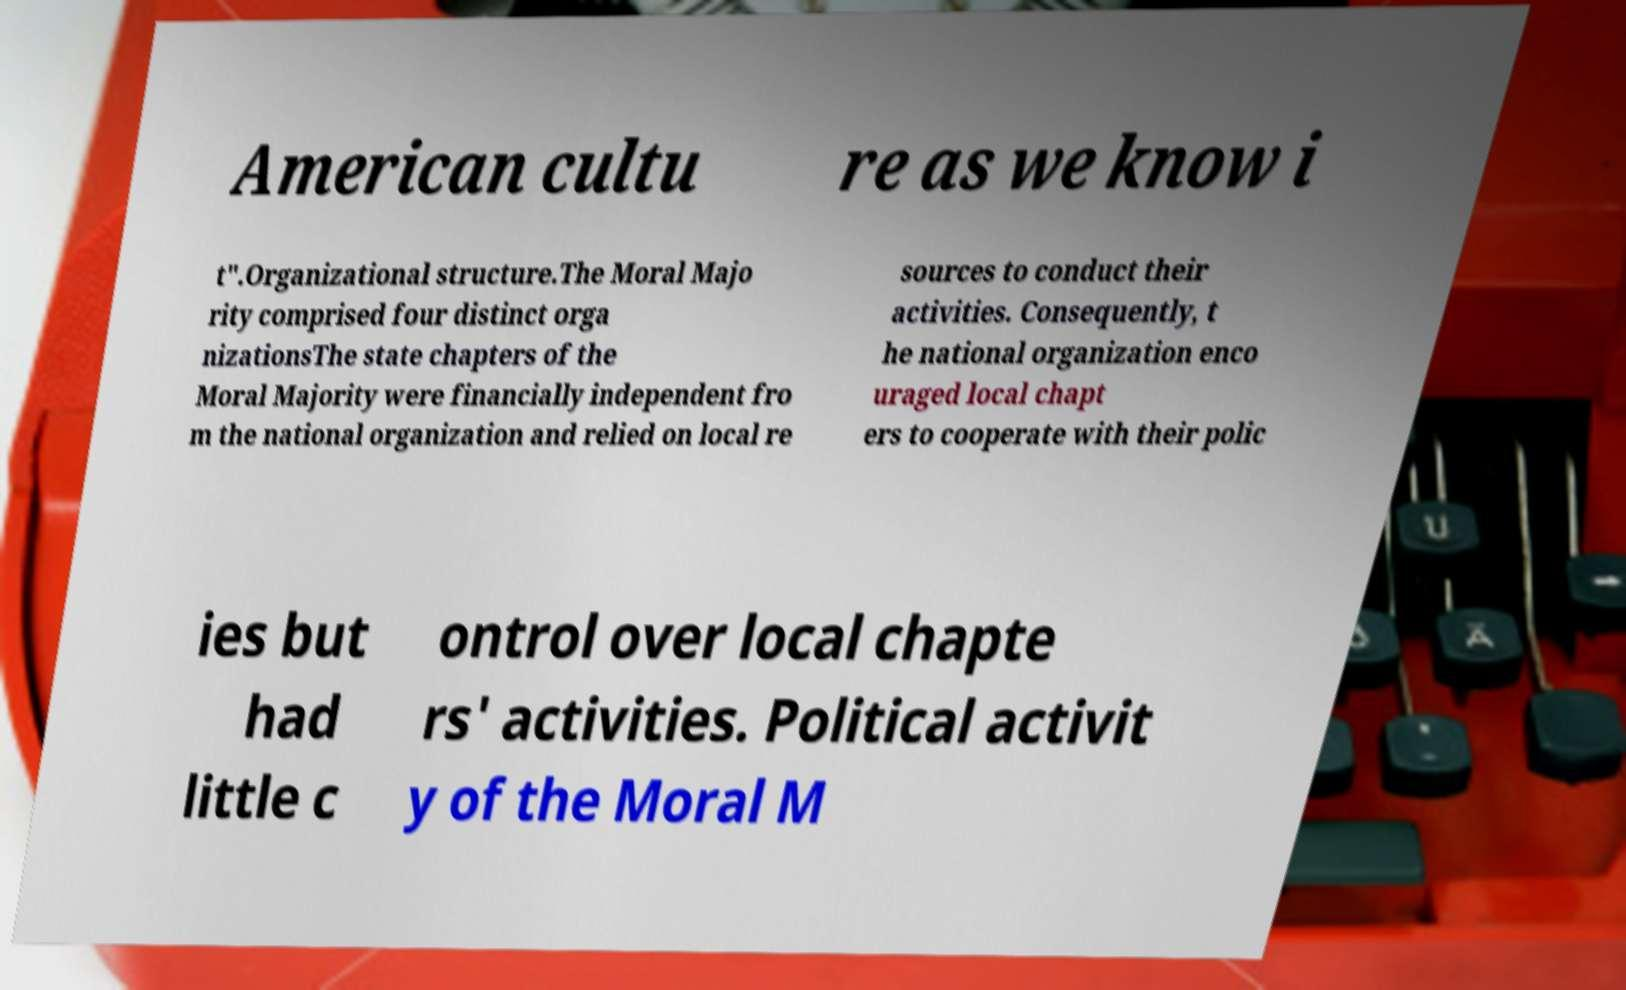Please identify and transcribe the text found in this image. American cultu re as we know i t".Organizational structure.The Moral Majo rity comprised four distinct orga nizationsThe state chapters of the Moral Majority were financially independent fro m the national organization and relied on local re sources to conduct their activities. Consequently, t he national organization enco uraged local chapt ers to cooperate with their polic ies but had little c ontrol over local chapte rs' activities. Political activit y of the Moral M 